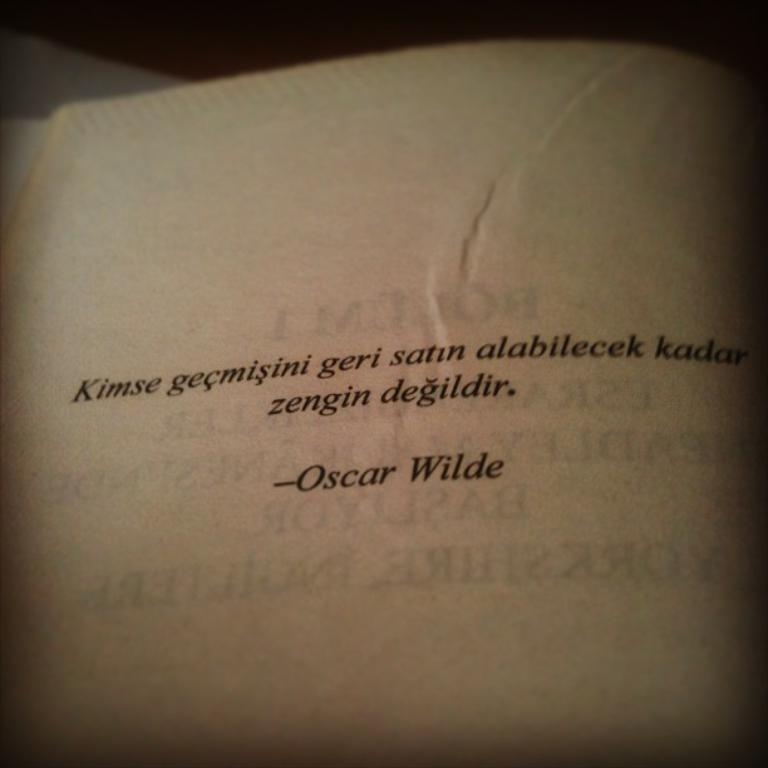<image>
Describe the image concisely. A Oscar Wilde quote written on old white paper. 